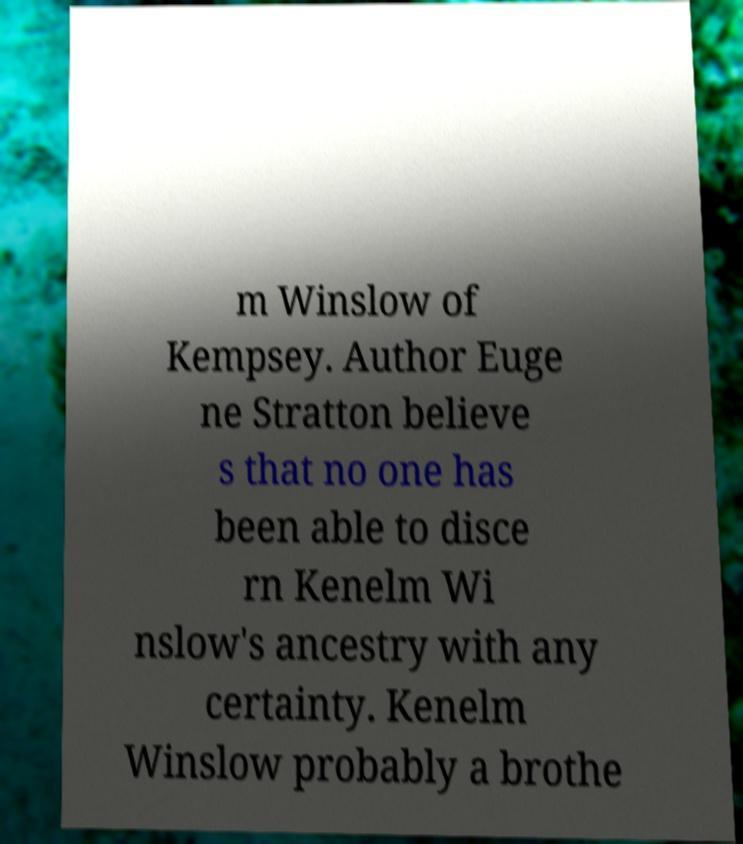Can you accurately transcribe the text from the provided image for me? m Winslow of Kempsey. Author Euge ne Stratton believe s that no one has been able to disce rn Kenelm Wi nslow's ancestry with any certainty. Kenelm Winslow probably a brothe 